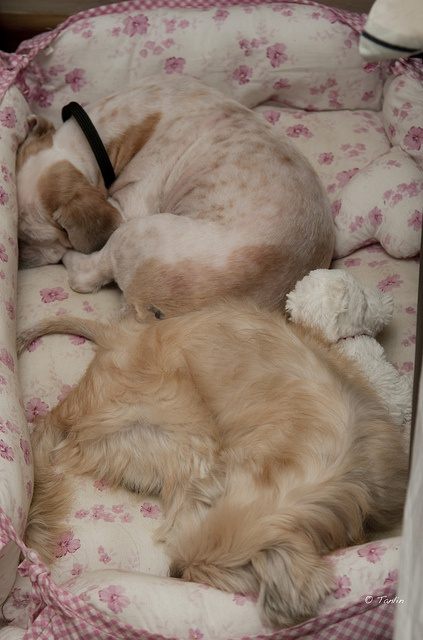Describe the objects in this image and their specific colors. I can see bed in darkgray, gray, and black tones, dog in black, gray, and tan tones, and dog in black, darkgray, and gray tones in this image. 